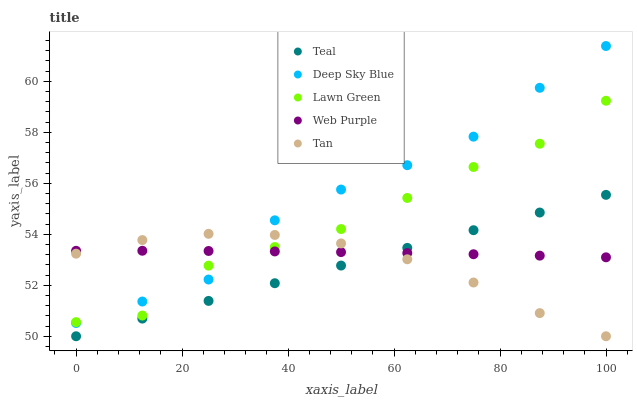Does Teal have the minimum area under the curve?
Answer yes or no. Yes. Does Deep Sky Blue have the maximum area under the curve?
Answer yes or no. Yes. Does Web Purple have the minimum area under the curve?
Answer yes or no. No. Does Web Purple have the maximum area under the curve?
Answer yes or no. No. Is Teal the smoothest?
Answer yes or no. Yes. Is Lawn Green the roughest?
Answer yes or no. Yes. Is Web Purple the smoothest?
Answer yes or no. No. Is Web Purple the roughest?
Answer yes or no. No. Does Tan have the lowest value?
Answer yes or no. Yes. Does Web Purple have the lowest value?
Answer yes or no. No. Does Deep Sky Blue have the highest value?
Answer yes or no. Yes. Does Tan have the highest value?
Answer yes or no. No. Is Teal less than Deep Sky Blue?
Answer yes or no. Yes. Is Lawn Green greater than Teal?
Answer yes or no. Yes. Does Deep Sky Blue intersect Web Purple?
Answer yes or no. Yes. Is Deep Sky Blue less than Web Purple?
Answer yes or no. No. Is Deep Sky Blue greater than Web Purple?
Answer yes or no. No. Does Teal intersect Deep Sky Blue?
Answer yes or no. No. 